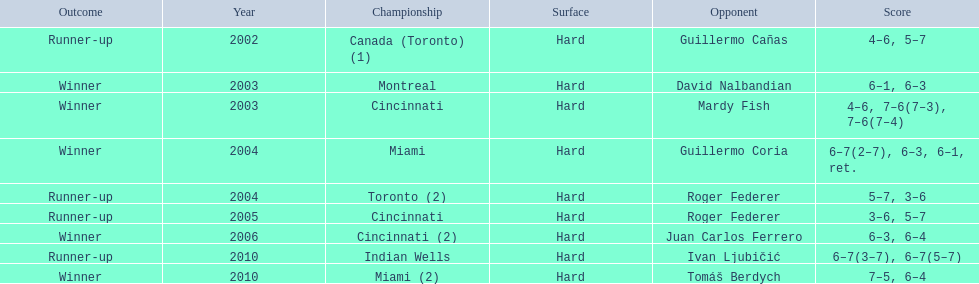How many instances has he been the second-place finisher? 4. 